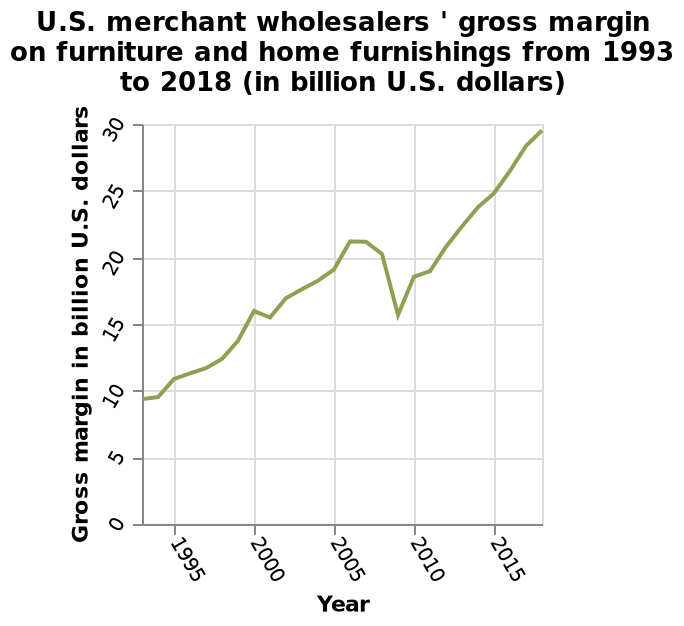<image>
What is the title of the line plot? The title of the line plot is "U.S. merchant wholesalers' gross margin on furniture and home furnishings from 1993 to 2018 (in billion U.S. dollars)." What was the overall Gross Margin in 1993? The overall Gross Margin in 1993 was 10 billion. please enumerates aspects of the construction of the chart This line plot is titled U.S. merchant wholesalers ' gross margin on furniture and home furnishings from 1993 to 2018 (in billion U.S. dollars). The x-axis measures Year as linear scale with a minimum of 1995 and a maximum of 2015 while the y-axis shows Gross margin in billion U.S. dollars using linear scale from 0 to 30. When did the slight dip in Gross Margin occur? The slight dip in Gross Margin occurred around 2007/2008. Is the title of the line plot "U.S. merchant wholesalers' gross margin on furniture and home furnishings from 1993 to 2018 (in trillion U.S. dollars)"? No.The title of the line plot is "U.S. merchant wholesalers' gross margin on furniture and home furnishings from 1993 to 2018 (in billion U.S. dollars)." 